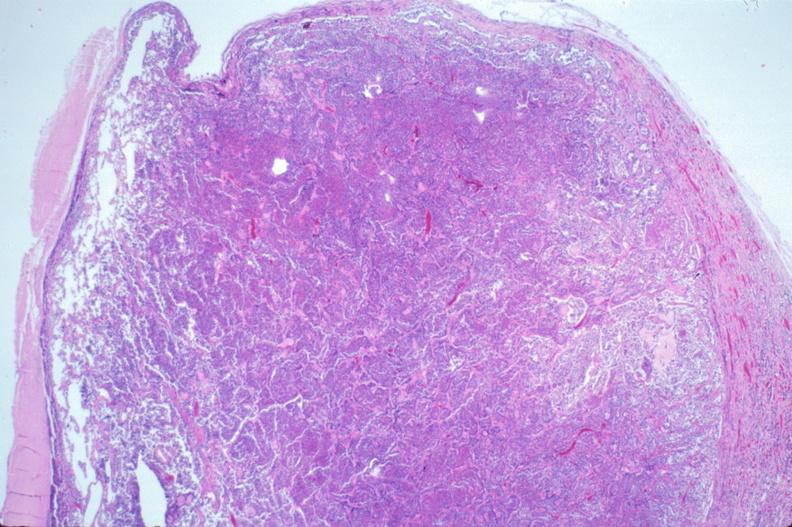s endocrine present?
Answer the question using a single word or phrase. Yes 